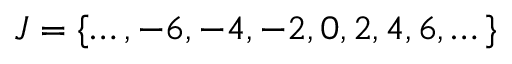<formula> <loc_0><loc_0><loc_500><loc_500>J = \{ \dots , - 6 , - 4 , - 2 , 0 , 2 , 4 , 6 , \dots \}</formula> 